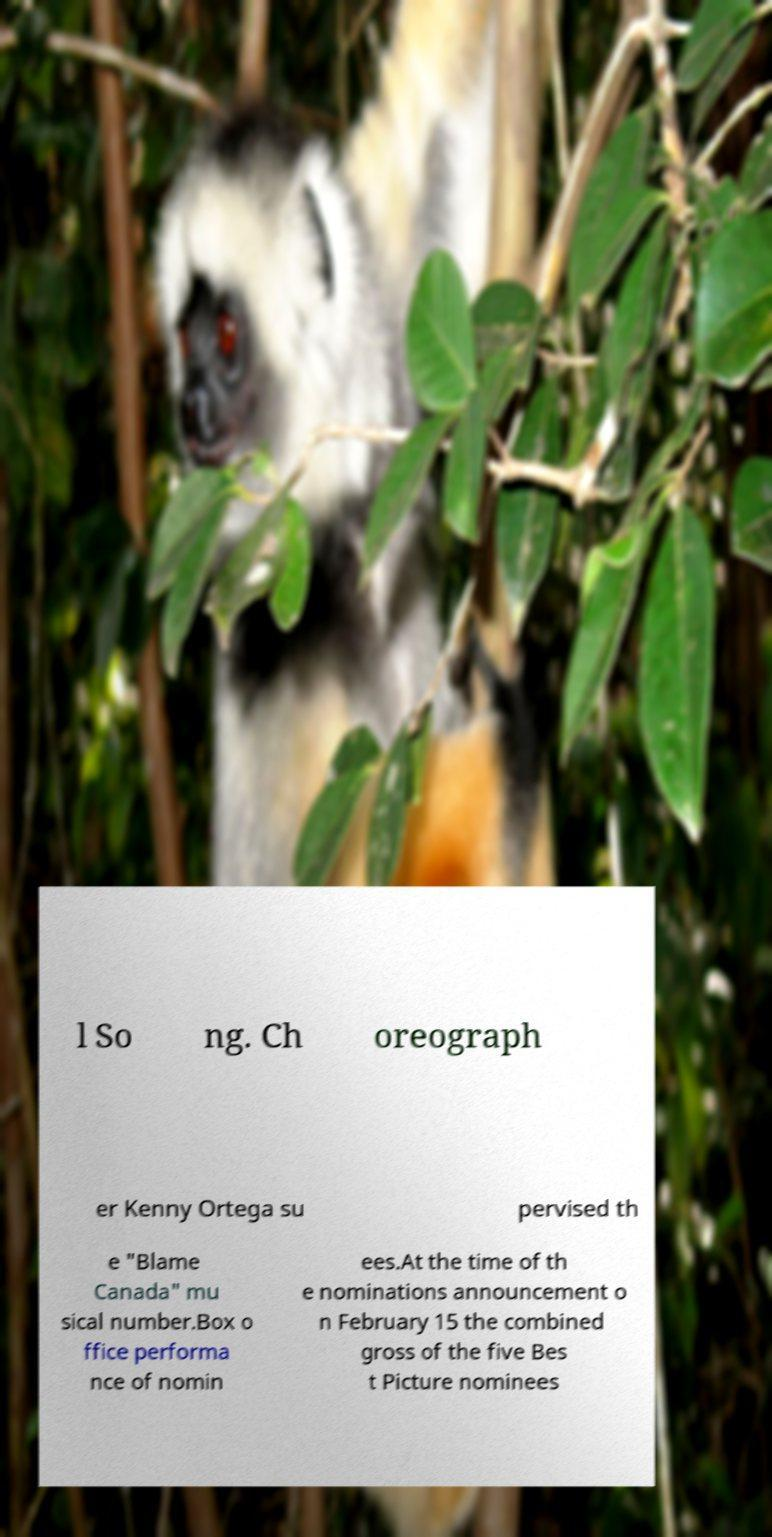What messages or text are displayed in this image? I need them in a readable, typed format. l So ng. Ch oreograph er Kenny Ortega su pervised th e "Blame Canada" mu sical number.Box o ffice performa nce of nomin ees.At the time of th e nominations announcement o n February 15 the combined gross of the five Bes t Picture nominees 